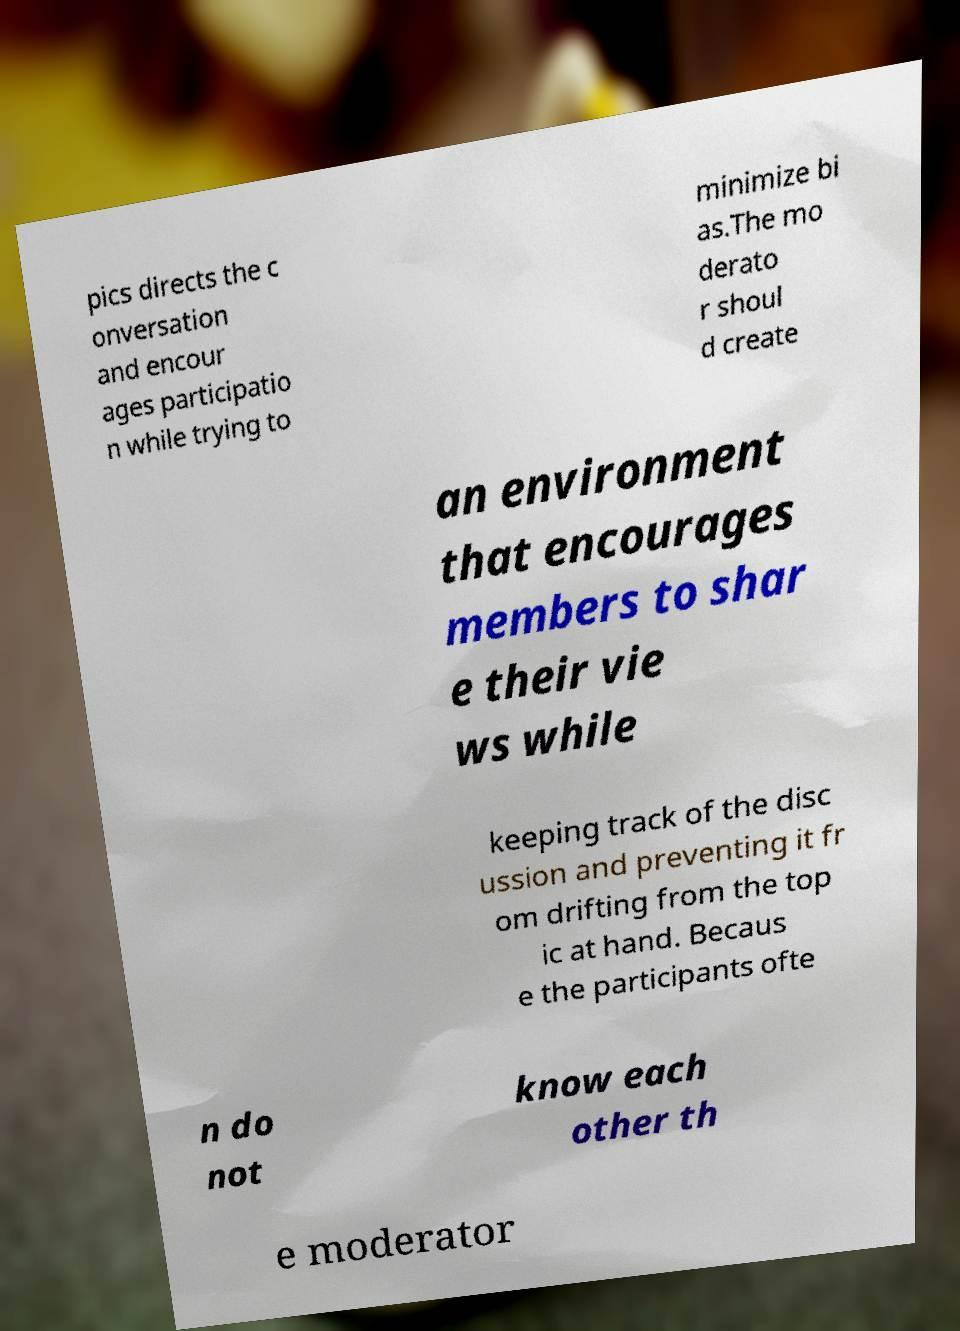Can you read and provide the text displayed in the image?This photo seems to have some interesting text. Can you extract and type it out for me? pics directs the c onversation and encour ages participatio n while trying to minimize bi as.The mo derato r shoul d create an environment that encourages members to shar e their vie ws while keeping track of the disc ussion and preventing it fr om drifting from the top ic at hand. Becaus e the participants ofte n do not know each other th e moderator 